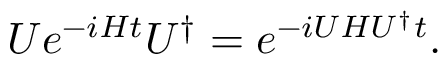Convert formula to latex. <formula><loc_0><loc_0><loc_500><loc_500>U e ^ { - i H t } U ^ { \dagger } = e ^ { - i U H U ^ { \dagger } t } .</formula> 